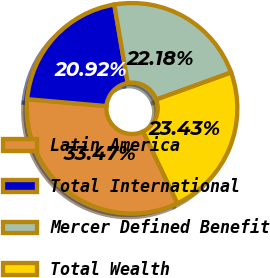Convert chart. <chart><loc_0><loc_0><loc_500><loc_500><pie_chart><fcel>Latin America<fcel>Total International<fcel>Mercer Defined Benefit<fcel>Total Wealth<nl><fcel>33.47%<fcel>20.92%<fcel>22.18%<fcel>23.43%<nl></chart> 